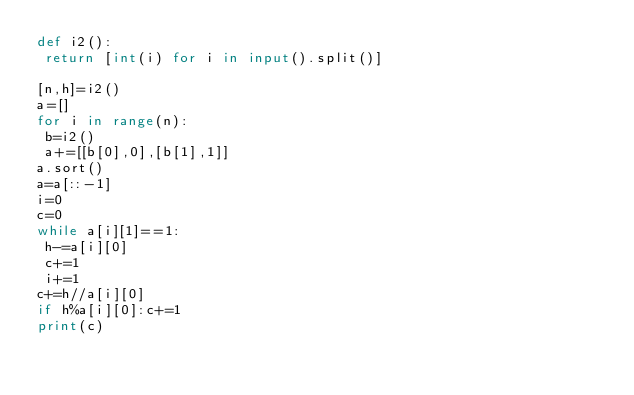Convert code to text. <code><loc_0><loc_0><loc_500><loc_500><_Python_>def i2():
 return [int(i) for i in input().split()]

[n,h]=i2()
a=[]
for i in range(n):
 b=i2()
 a+=[[b[0],0],[b[1],1]]
a.sort()
a=a[::-1]
i=0
c=0
while a[i][1]==1:
 h-=a[i][0]
 c+=1
 i+=1
c+=h//a[i][0]
if h%a[i][0]:c+=1
print(c)</code> 